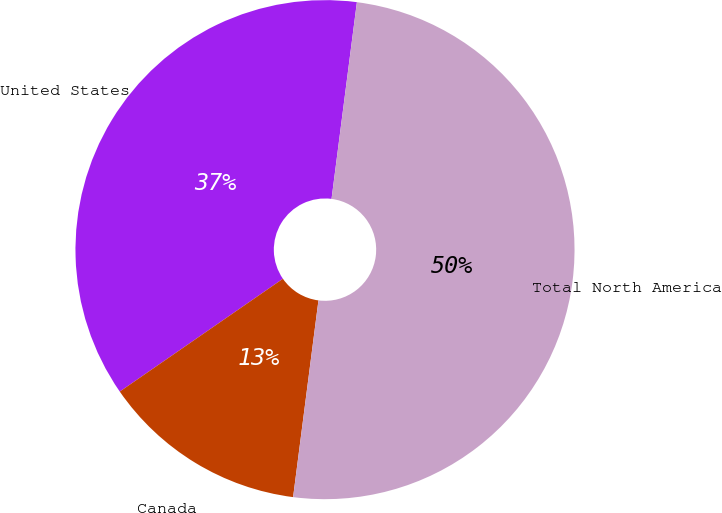Convert chart to OTSL. <chart><loc_0><loc_0><loc_500><loc_500><pie_chart><fcel>United States<fcel>Canada<fcel>Total North America<nl><fcel>36.67%<fcel>13.33%<fcel>50.0%<nl></chart> 